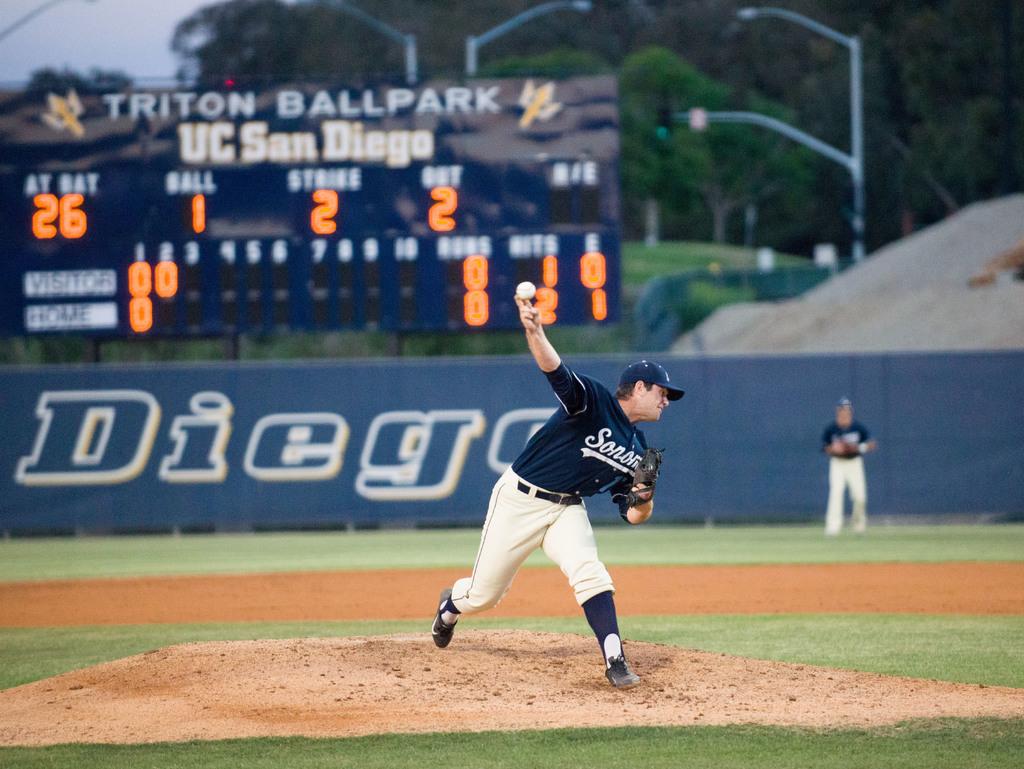What is the name of the ballpark?
Provide a short and direct response. Triton ballpark. Where is this ballpark located?
Give a very brief answer. San diego. 